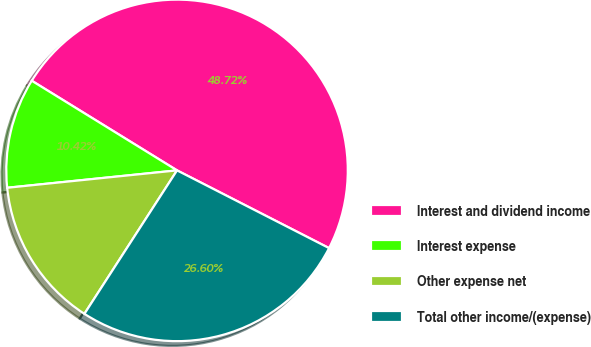<chart> <loc_0><loc_0><loc_500><loc_500><pie_chart><fcel>Interest and dividend income<fcel>Interest expense<fcel>Other expense net<fcel>Total other income/(expense)<nl><fcel>48.72%<fcel>10.42%<fcel>14.25%<fcel>26.6%<nl></chart> 